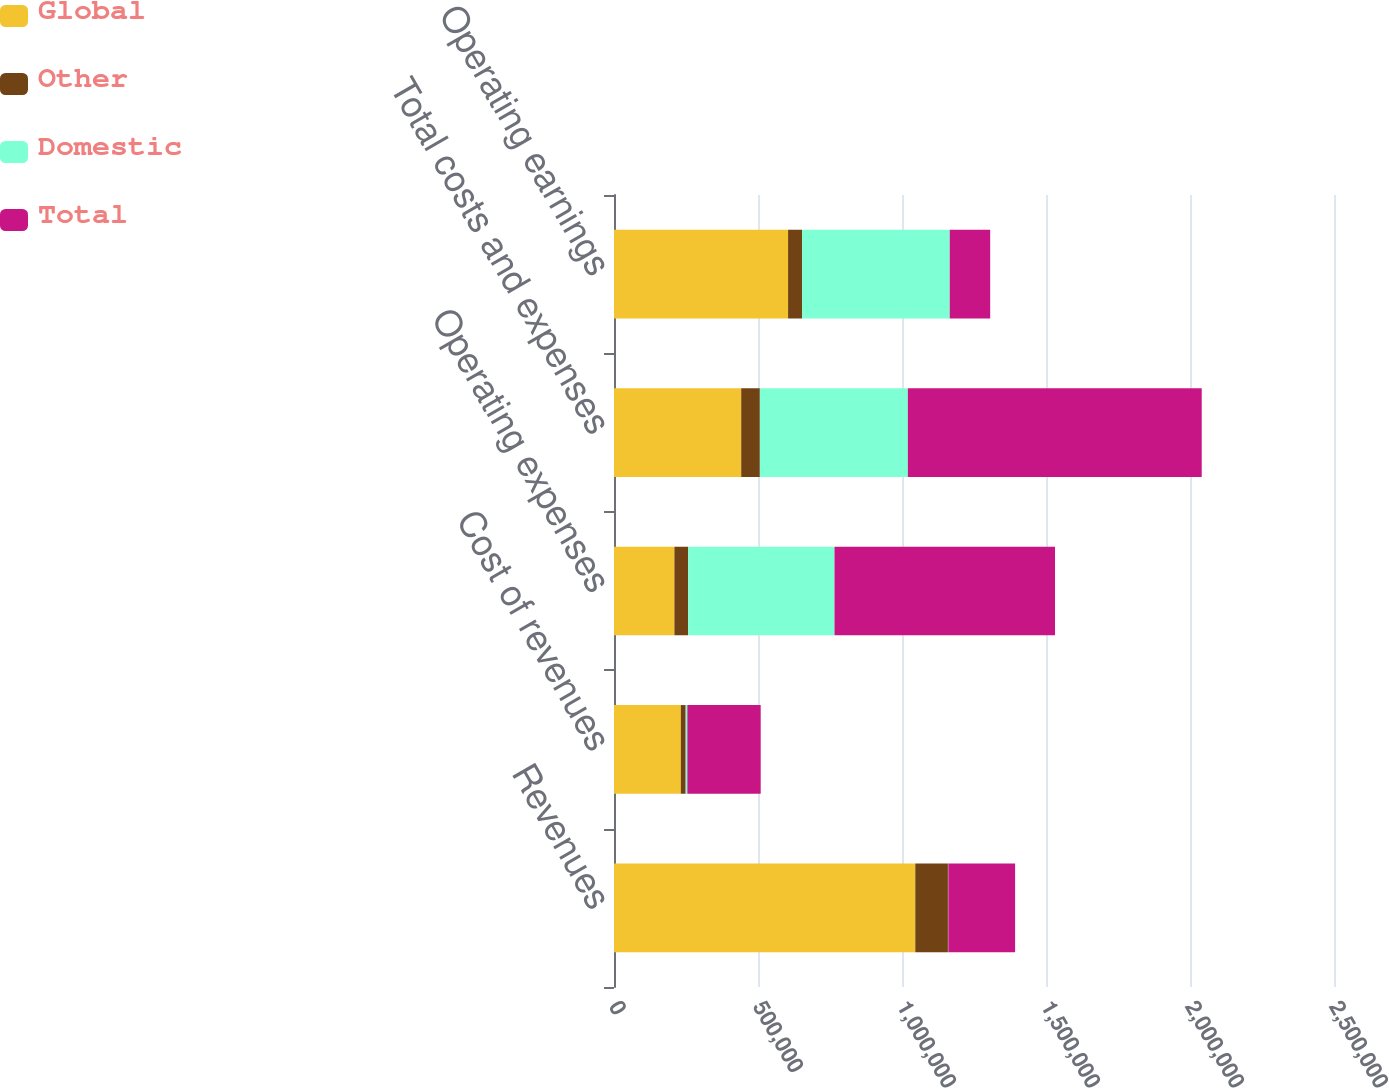Convert chart. <chart><loc_0><loc_0><loc_500><loc_500><stacked_bar_chart><ecel><fcel>Revenues<fcel>Cost of revenues<fcel>Operating expenses<fcel>Total costs and expenses<fcel>Operating earnings<nl><fcel>Global<fcel>1.04618e+06<fcel>231977<fcel>209747<fcel>441724<fcel>604456<nl><fcel>Other<fcel>113314<fcel>16981<fcel>47691<fcel>64672<fcel>48642<nl><fcel>Domestic<fcel>1290<fcel>5728<fcel>508224<fcel>513952<fcel>512662<nl><fcel>Total<fcel>231977<fcel>254686<fcel>765663<fcel>1.02035e+06<fcel>140436<nl></chart> 